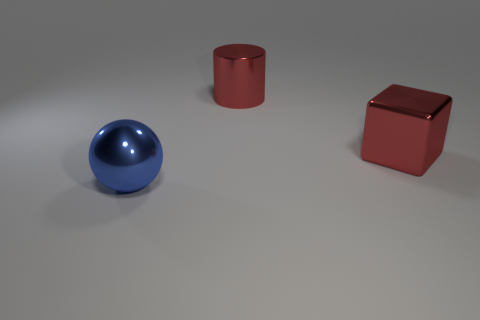Is there any other thing that is the same size as the metal cube?
Give a very brief answer. Yes. Are there any large red metal things that are to the left of the red metal object on the left side of the metal block?
Provide a short and direct response. No. There is a red thing behind the large red block; does it have the same shape as the blue object?
Give a very brief answer. No. What number of big cylinders are the same material as the cube?
Keep it short and to the point. 1. Is the color of the big cylinder the same as the object in front of the metal cube?
Give a very brief answer. No. How many large red metal cylinders are there?
Your response must be concise. 1. Are there any rubber spheres of the same color as the large cylinder?
Provide a succinct answer. No. The big object that is to the left of the red thing that is behind the red shiny thing to the right of the large red metal cylinder is what color?
Your response must be concise. Blue. Do the large red cylinder and the big blue sphere on the left side of the big cube have the same material?
Provide a short and direct response. Yes. What is the material of the large red cube?
Give a very brief answer. Metal. 